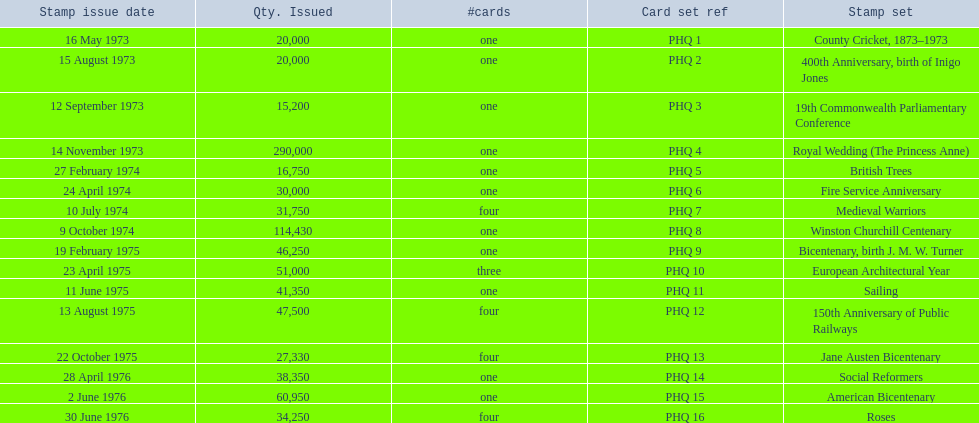Which stamp sets had three or more cards? Medieval Warriors, European Architectural Year, 150th Anniversary of Public Railways, Jane Austen Bicentenary, Roses. Of those, which one only has three cards? European Architectural Year. 